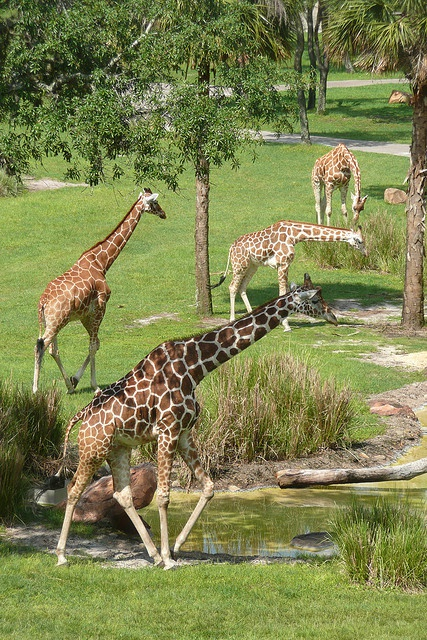Describe the objects in this image and their specific colors. I can see giraffe in black, olive, maroon, and gray tones, giraffe in black, olive, salmon, and gray tones, giraffe in black, ivory, tan, and gray tones, and giraffe in black, beige, and tan tones in this image. 